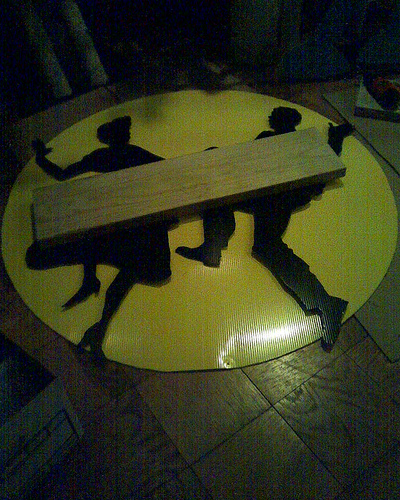<image>
Is the man next to the moon? No. The man is not positioned next to the moon. They are located in different areas of the scene. 